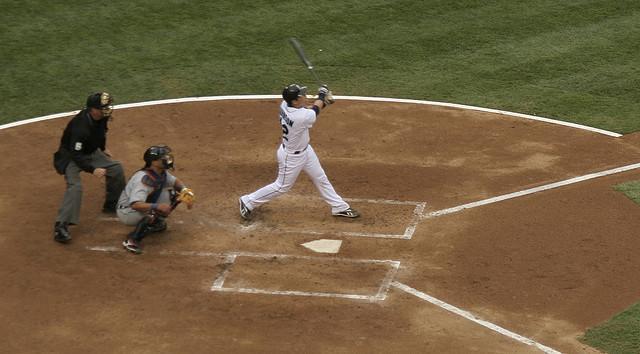How many people can you see?
Give a very brief answer. 3. 